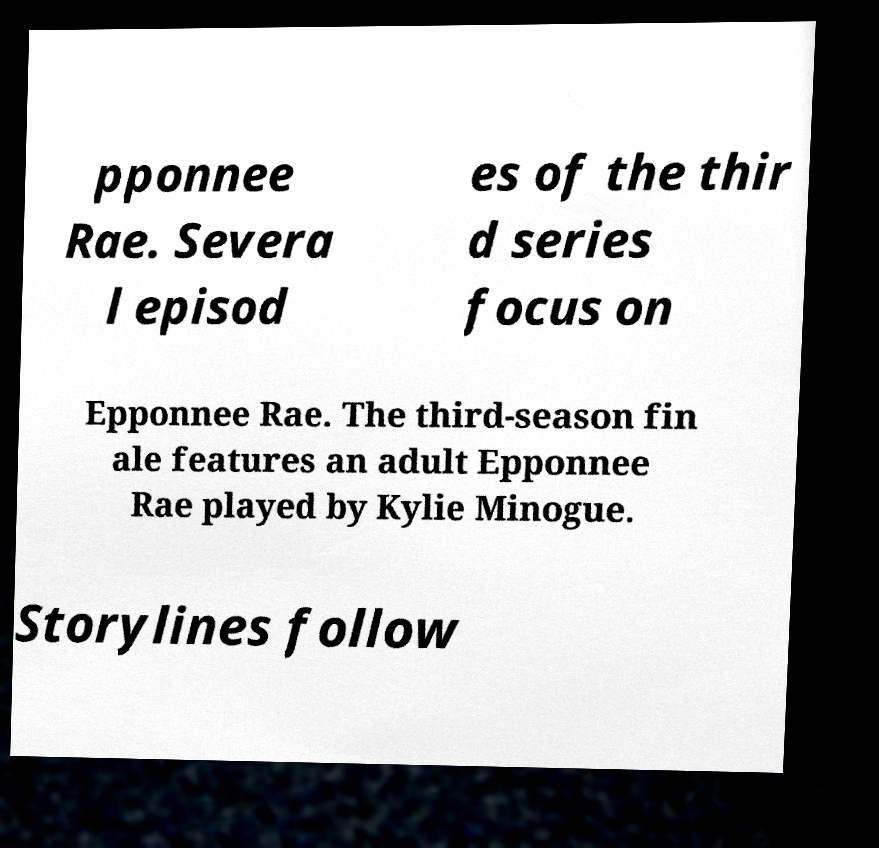There's text embedded in this image that I need extracted. Can you transcribe it verbatim? pponnee Rae. Severa l episod es of the thir d series focus on Epponnee Rae. The third-season fin ale features an adult Epponnee Rae played by Kylie Minogue. Storylines follow 